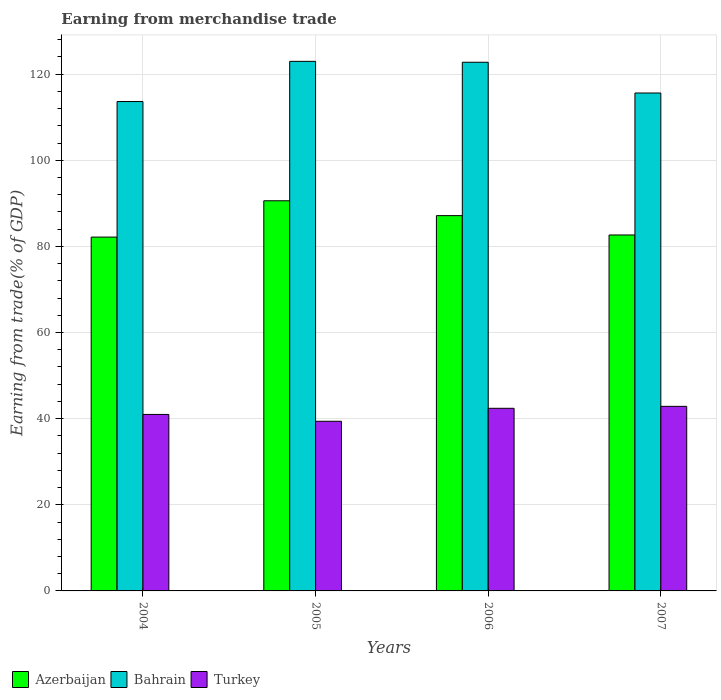How many groups of bars are there?
Provide a short and direct response. 4. Are the number of bars on each tick of the X-axis equal?
Your answer should be compact. Yes. How many bars are there on the 1st tick from the right?
Provide a succinct answer. 3. What is the label of the 3rd group of bars from the left?
Your answer should be very brief. 2006. In how many cases, is the number of bars for a given year not equal to the number of legend labels?
Your answer should be very brief. 0. What is the earnings from trade in Turkey in 2006?
Your answer should be very brief. 42.4. Across all years, what is the maximum earnings from trade in Azerbaijan?
Offer a terse response. 90.59. Across all years, what is the minimum earnings from trade in Bahrain?
Your answer should be compact. 113.63. In which year was the earnings from trade in Azerbaijan minimum?
Offer a very short reply. 2004. What is the total earnings from trade in Bahrain in the graph?
Provide a short and direct response. 474.95. What is the difference between the earnings from trade in Azerbaijan in 2004 and that in 2006?
Provide a short and direct response. -4.98. What is the difference between the earnings from trade in Azerbaijan in 2007 and the earnings from trade in Bahrain in 2005?
Offer a terse response. -40.31. What is the average earnings from trade in Azerbaijan per year?
Ensure brevity in your answer.  85.63. In the year 2005, what is the difference between the earnings from trade in Azerbaijan and earnings from trade in Turkey?
Provide a short and direct response. 51.2. In how many years, is the earnings from trade in Bahrain greater than 40 %?
Keep it short and to the point. 4. What is the ratio of the earnings from trade in Bahrain in 2005 to that in 2006?
Offer a very short reply. 1. Is the earnings from trade in Bahrain in 2004 less than that in 2005?
Give a very brief answer. Yes. Is the difference between the earnings from trade in Azerbaijan in 2005 and 2006 greater than the difference between the earnings from trade in Turkey in 2005 and 2006?
Provide a short and direct response. Yes. What is the difference between the highest and the second highest earnings from trade in Turkey?
Make the answer very short. 0.45. What is the difference between the highest and the lowest earnings from trade in Azerbaijan?
Make the answer very short. 8.43. Is the sum of the earnings from trade in Turkey in 2004 and 2007 greater than the maximum earnings from trade in Azerbaijan across all years?
Your answer should be very brief. No. What does the 2nd bar from the left in 2005 represents?
Offer a terse response. Bahrain. What does the 2nd bar from the right in 2005 represents?
Ensure brevity in your answer.  Bahrain. Is it the case that in every year, the sum of the earnings from trade in Azerbaijan and earnings from trade in Turkey is greater than the earnings from trade in Bahrain?
Offer a terse response. Yes. Are all the bars in the graph horizontal?
Offer a terse response. No. Does the graph contain any zero values?
Make the answer very short. No. Where does the legend appear in the graph?
Offer a very short reply. Bottom left. What is the title of the graph?
Make the answer very short. Earning from merchandise trade. What is the label or title of the X-axis?
Your answer should be compact. Years. What is the label or title of the Y-axis?
Provide a short and direct response. Earning from trade(% of GDP). What is the Earning from trade(% of GDP) of Azerbaijan in 2004?
Give a very brief answer. 82.15. What is the Earning from trade(% of GDP) of Bahrain in 2004?
Make the answer very short. 113.63. What is the Earning from trade(% of GDP) of Turkey in 2004?
Your answer should be compact. 40.98. What is the Earning from trade(% of GDP) of Azerbaijan in 2005?
Your answer should be compact. 90.59. What is the Earning from trade(% of GDP) of Bahrain in 2005?
Your response must be concise. 122.96. What is the Earning from trade(% of GDP) in Turkey in 2005?
Your answer should be compact. 39.39. What is the Earning from trade(% of GDP) in Azerbaijan in 2006?
Ensure brevity in your answer.  87.14. What is the Earning from trade(% of GDP) of Bahrain in 2006?
Your response must be concise. 122.75. What is the Earning from trade(% of GDP) in Turkey in 2006?
Ensure brevity in your answer.  42.4. What is the Earning from trade(% of GDP) in Azerbaijan in 2007?
Give a very brief answer. 82.64. What is the Earning from trade(% of GDP) of Bahrain in 2007?
Ensure brevity in your answer.  115.61. What is the Earning from trade(% of GDP) in Turkey in 2007?
Offer a very short reply. 42.85. Across all years, what is the maximum Earning from trade(% of GDP) in Azerbaijan?
Make the answer very short. 90.59. Across all years, what is the maximum Earning from trade(% of GDP) in Bahrain?
Give a very brief answer. 122.96. Across all years, what is the maximum Earning from trade(% of GDP) in Turkey?
Provide a short and direct response. 42.85. Across all years, what is the minimum Earning from trade(% of GDP) in Azerbaijan?
Your answer should be compact. 82.15. Across all years, what is the minimum Earning from trade(% of GDP) of Bahrain?
Provide a succinct answer. 113.63. Across all years, what is the minimum Earning from trade(% of GDP) of Turkey?
Your response must be concise. 39.39. What is the total Earning from trade(% of GDP) of Azerbaijan in the graph?
Keep it short and to the point. 342.52. What is the total Earning from trade(% of GDP) of Bahrain in the graph?
Your answer should be compact. 474.95. What is the total Earning from trade(% of GDP) of Turkey in the graph?
Your answer should be very brief. 165.63. What is the difference between the Earning from trade(% of GDP) of Azerbaijan in 2004 and that in 2005?
Your answer should be very brief. -8.43. What is the difference between the Earning from trade(% of GDP) in Bahrain in 2004 and that in 2005?
Give a very brief answer. -9.33. What is the difference between the Earning from trade(% of GDP) in Turkey in 2004 and that in 2005?
Your response must be concise. 1.59. What is the difference between the Earning from trade(% of GDP) in Azerbaijan in 2004 and that in 2006?
Give a very brief answer. -4.98. What is the difference between the Earning from trade(% of GDP) of Bahrain in 2004 and that in 2006?
Keep it short and to the point. -9.12. What is the difference between the Earning from trade(% of GDP) of Turkey in 2004 and that in 2006?
Provide a short and direct response. -1.42. What is the difference between the Earning from trade(% of GDP) of Azerbaijan in 2004 and that in 2007?
Make the answer very short. -0.49. What is the difference between the Earning from trade(% of GDP) in Bahrain in 2004 and that in 2007?
Your response must be concise. -1.98. What is the difference between the Earning from trade(% of GDP) of Turkey in 2004 and that in 2007?
Provide a succinct answer. -1.88. What is the difference between the Earning from trade(% of GDP) in Azerbaijan in 2005 and that in 2006?
Keep it short and to the point. 3.45. What is the difference between the Earning from trade(% of GDP) of Bahrain in 2005 and that in 2006?
Make the answer very short. 0.21. What is the difference between the Earning from trade(% of GDP) in Turkey in 2005 and that in 2006?
Your answer should be very brief. -3.01. What is the difference between the Earning from trade(% of GDP) of Azerbaijan in 2005 and that in 2007?
Offer a very short reply. 7.94. What is the difference between the Earning from trade(% of GDP) of Bahrain in 2005 and that in 2007?
Provide a short and direct response. 7.35. What is the difference between the Earning from trade(% of GDP) in Turkey in 2005 and that in 2007?
Offer a terse response. -3.46. What is the difference between the Earning from trade(% of GDP) in Azerbaijan in 2006 and that in 2007?
Your response must be concise. 4.49. What is the difference between the Earning from trade(% of GDP) of Bahrain in 2006 and that in 2007?
Keep it short and to the point. 7.14. What is the difference between the Earning from trade(% of GDP) of Turkey in 2006 and that in 2007?
Provide a short and direct response. -0.45. What is the difference between the Earning from trade(% of GDP) of Azerbaijan in 2004 and the Earning from trade(% of GDP) of Bahrain in 2005?
Keep it short and to the point. -40.81. What is the difference between the Earning from trade(% of GDP) of Azerbaijan in 2004 and the Earning from trade(% of GDP) of Turkey in 2005?
Make the answer very short. 42.76. What is the difference between the Earning from trade(% of GDP) of Bahrain in 2004 and the Earning from trade(% of GDP) of Turkey in 2005?
Make the answer very short. 74.24. What is the difference between the Earning from trade(% of GDP) in Azerbaijan in 2004 and the Earning from trade(% of GDP) in Bahrain in 2006?
Provide a short and direct response. -40.6. What is the difference between the Earning from trade(% of GDP) of Azerbaijan in 2004 and the Earning from trade(% of GDP) of Turkey in 2006?
Your answer should be very brief. 39.75. What is the difference between the Earning from trade(% of GDP) in Bahrain in 2004 and the Earning from trade(% of GDP) in Turkey in 2006?
Keep it short and to the point. 71.23. What is the difference between the Earning from trade(% of GDP) in Azerbaijan in 2004 and the Earning from trade(% of GDP) in Bahrain in 2007?
Provide a short and direct response. -33.46. What is the difference between the Earning from trade(% of GDP) of Azerbaijan in 2004 and the Earning from trade(% of GDP) of Turkey in 2007?
Your answer should be compact. 39.3. What is the difference between the Earning from trade(% of GDP) in Bahrain in 2004 and the Earning from trade(% of GDP) in Turkey in 2007?
Your answer should be very brief. 70.78. What is the difference between the Earning from trade(% of GDP) of Azerbaijan in 2005 and the Earning from trade(% of GDP) of Bahrain in 2006?
Provide a succinct answer. -32.16. What is the difference between the Earning from trade(% of GDP) in Azerbaijan in 2005 and the Earning from trade(% of GDP) in Turkey in 2006?
Make the answer very short. 48.19. What is the difference between the Earning from trade(% of GDP) in Bahrain in 2005 and the Earning from trade(% of GDP) in Turkey in 2006?
Your response must be concise. 80.56. What is the difference between the Earning from trade(% of GDP) in Azerbaijan in 2005 and the Earning from trade(% of GDP) in Bahrain in 2007?
Make the answer very short. -25.02. What is the difference between the Earning from trade(% of GDP) in Azerbaijan in 2005 and the Earning from trade(% of GDP) in Turkey in 2007?
Give a very brief answer. 47.73. What is the difference between the Earning from trade(% of GDP) in Bahrain in 2005 and the Earning from trade(% of GDP) in Turkey in 2007?
Your answer should be compact. 80.11. What is the difference between the Earning from trade(% of GDP) of Azerbaijan in 2006 and the Earning from trade(% of GDP) of Bahrain in 2007?
Keep it short and to the point. -28.47. What is the difference between the Earning from trade(% of GDP) of Azerbaijan in 2006 and the Earning from trade(% of GDP) of Turkey in 2007?
Your answer should be compact. 44.28. What is the difference between the Earning from trade(% of GDP) in Bahrain in 2006 and the Earning from trade(% of GDP) in Turkey in 2007?
Your answer should be compact. 79.9. What is the average Earning from trade(% of GDP) of Azerbaijan per year?
Your answer should be very brief. 85.63. What is the average Earning from trade(% of GDP) of Bahrain per year?
Offer a terse response. 118.74. What is the average Earning from trade(% of GDP) in Turkey per year?
Give a very brief answer. 41.41. In the year 2004, what is the difference between the Earning from trade(% of GDP) in Azerbaijan and Earning from trade(% of GDP) in Bahrain?
Your response must be concise. -31.48. In the year 2004, what is the difference between the Earning from trade(% of GDP) of Azerbaijan and Earning from trade(% of GDP) of Turkey?
Keep it short and to the point. 41.17. In the year 2004, what is the difference between the Earning from trade(% of GDP) of Bahrain and Earning from trade(% of GDP) of Turkey?
Keep it short and to the point. 72.65. In the year 2005, what is the difference between the Earning from trade(% of GDP) in Azerbaijan and Earning from trade(% of GDP) in Bahrain?
Give a very brief answer. -32.37. In the year 2005, what is the difference between the Earning from trade(% of GDP) in Azerbaijan and Earning from trade(% of GDP) in Turkey?
Your answer should be compact. 51.2. In the year 2005, what is the difference between the Earning from trade(% of GDP) in Bahrain and Earning from trade(% of GDP) in Turkey?
Your answer should be very brief. 83.57. In the year 2006, what is the difference between the Earning from trade(% of GDP) of Azerbaijan and Earning from trade(% of GDP) of Bahrain?
Provide a succinct answer. -35.61. In the year 2006, what is the difference between the Earning from trade(% of GDP) in Azerbaijan and Earning from trade(% of GDP) in Turkey?
Ensure brevity in your answer.  44.74. In the year 2006, what is the difference between the Earning from trade(% of GDP) in Bahrain and Earning from trade(% of GDP) in Turkey?
Offer a very short reply. 80.35. In the year 2007, what is the difference between the Earning from trade(% of GDP) in Azerbaijan and Earning from trade(% of GDP) in Bahrain?
Your answer should be very brief. -32.97. In the year 2007, what is the difference between the Earning from trade(% of GDP) of Azerbaijan and Earning from trade(% of GDP) of Turkey?
Make the answer very short. 39.79. In the year 2007, what is the difference between the Earning from trade(% of GDP) in Bahrain and Earning from trade(% of GDP) in Turkey?
Keep it short and to the point. 72.76. What is the ratio of the Earning from trade(% of GDP) in Azerbaijan in 2004 to that in 2005?
Your answer should be very brief. 0.91. What is the ratio of the Earning from trade(% of GDP) of Bahrain in 2004 to that in 2005?
Give a very brief answer. 0.92. What is the ratio of the Earning from trade(% of GDP) in Turkey in 2004 to that in 2005?
Offer a terse response. 1.04. What is the ratio of the Earning from trade(% of GDP) in Azerbaijan in 2004 to that in 2006?
Your response must be concise. 0.94. What is the ratio of the Earning from trade(% of GDP) in Bahrain in 2004 to that in 2006?
Your response must be concise. 0.93. What is the ratio of the Earning from trade(% of GDP) of Turkey in 2004 to that in 2006?
Offer a very short reply. 0.97. What is the ratio of the Earning from trade(% of GDP) in Azerbaijan in 2004 to that in 2007?
Offer a very short reply. 0.99. What is the ratio of the Earning from trade(% of GDP) of Bahrain in 2004 to that in 2007?
Provide a succinct answer. 0.98. What is the ratio of the Earning from trade(% of GDP) in Turkey in 2004 to that in 2007?
Offer a terse response. 0.96. What is the ratio of the Earning from trade(% of GDP) in Azerbaijan in 2005 to that in 2006?
Provide a short and direct response. 1.04. What is the ratio of the Earning from trade(% of GDP) of Turkey in 2005 to that in 2006?
Offer a very short reply. 0.93. What is the ratio of the Earning from trade(% of GDP) in Azerbaijan in 2005 to that in 2007?
Provide a succinct answer. 1.1. What is the ratio of the Earning from trade(% of GDP) of Bahrain in 2005 to that in 2007?
Your answer should be compact. 1.06. What is the ratio of the Earning from trade(% of GDP) in Turkey in 2005 to that in 2007?
Keep it short and to the point. 0.92. What is the ratio of the Earning from trade(% of GDP) in Azerbaijan in 2006 to that in 2007?
Offer a terse response. 1.05. What is the ratio of the Earning from trade(% of GDP) in Bahrain in 2006 to that in 2007?
Offer a very short reply. 1.06. What is the difference between the highest and the second highest Earning from trade(% of GDP) of Azerbaijan?
Make the answer very short. 3.45. What is the difference between the highest and the second highest Earning from trade(% of GDP) of Bahrain?
Give a very brief answer. 0.21. What is the difference between the highest and the second highest Earning from trade(% of GDP) in Turkey?
Ensure brevity in your answer.  0.45. What is the difference between the highest and the lowest Earning from trade(% of GDP) of Azerbaijan?
Keep it short and to the point. 8.43. What is the difference between the highest and the lowest Earning from trade(% of GDP) in Bahrain?
Keep it short and to the point. 9.33. What is the difference between the highest and the lowest Earning from trade(% of GDP) in Turkey?
Make the answer very short. 3.46. 